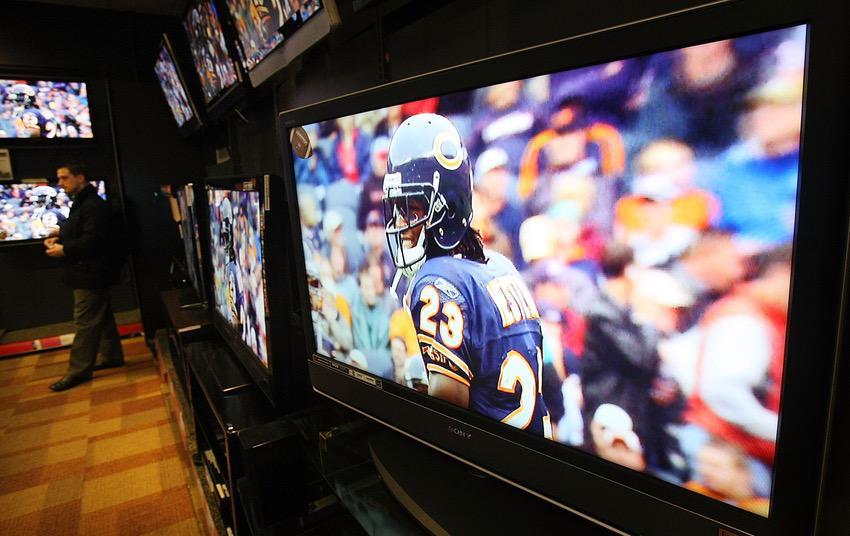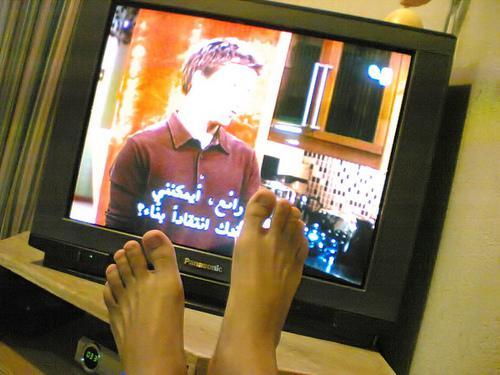The first image is the image on the left, the second image is the image on the right. Considering the images on both sides, is "An image shows multiple TV screens arranged one atop the other, and includes at least one non-standing person in front of a screen." valid? Answer yes or no. No. 